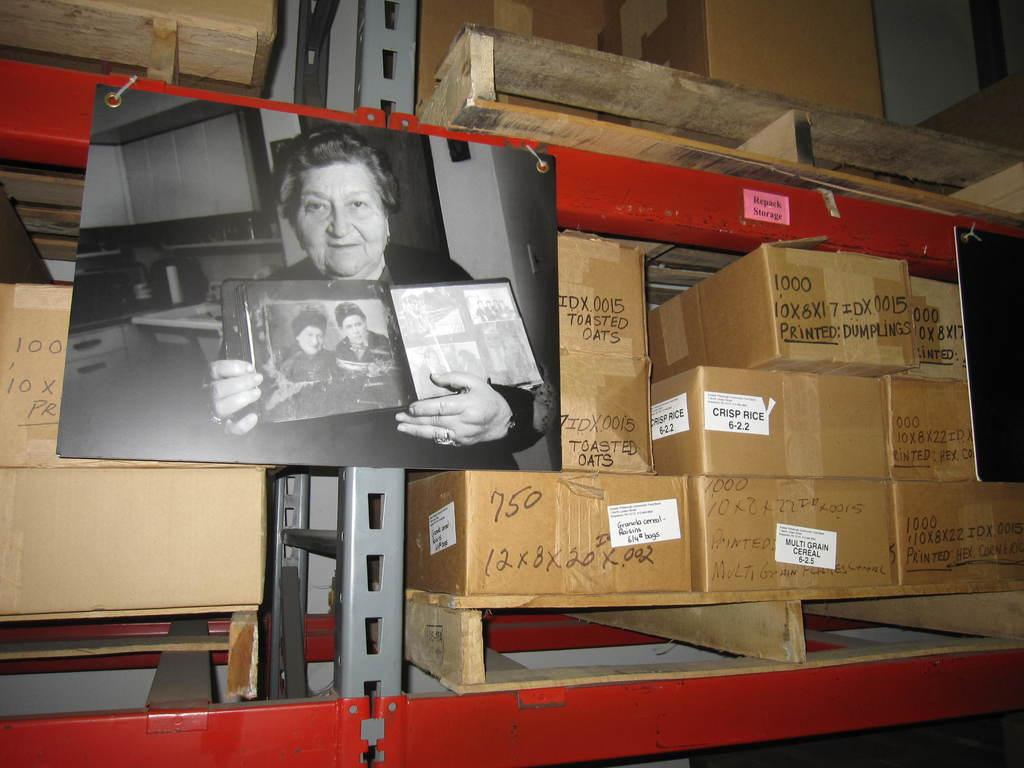What type of storage units are present in the image? There are shelves in the image. What items can be seen on the shelves? A: There are boxes and wooden objects visible on the shelves. What is the central focus of the image? There is a photograph in the center of the image. What is happening in the photograph? The photograph contains a woman holding a frame. How many bags can be seen in the image? There are no bags present in the image. What type of memory is stored in the wooden objects? The wooden objects in the image do not store memories; they are simply objects. Can you see a goose in the photograph? There is no goose present in the image, neither in the photograph nor elsewhere. 